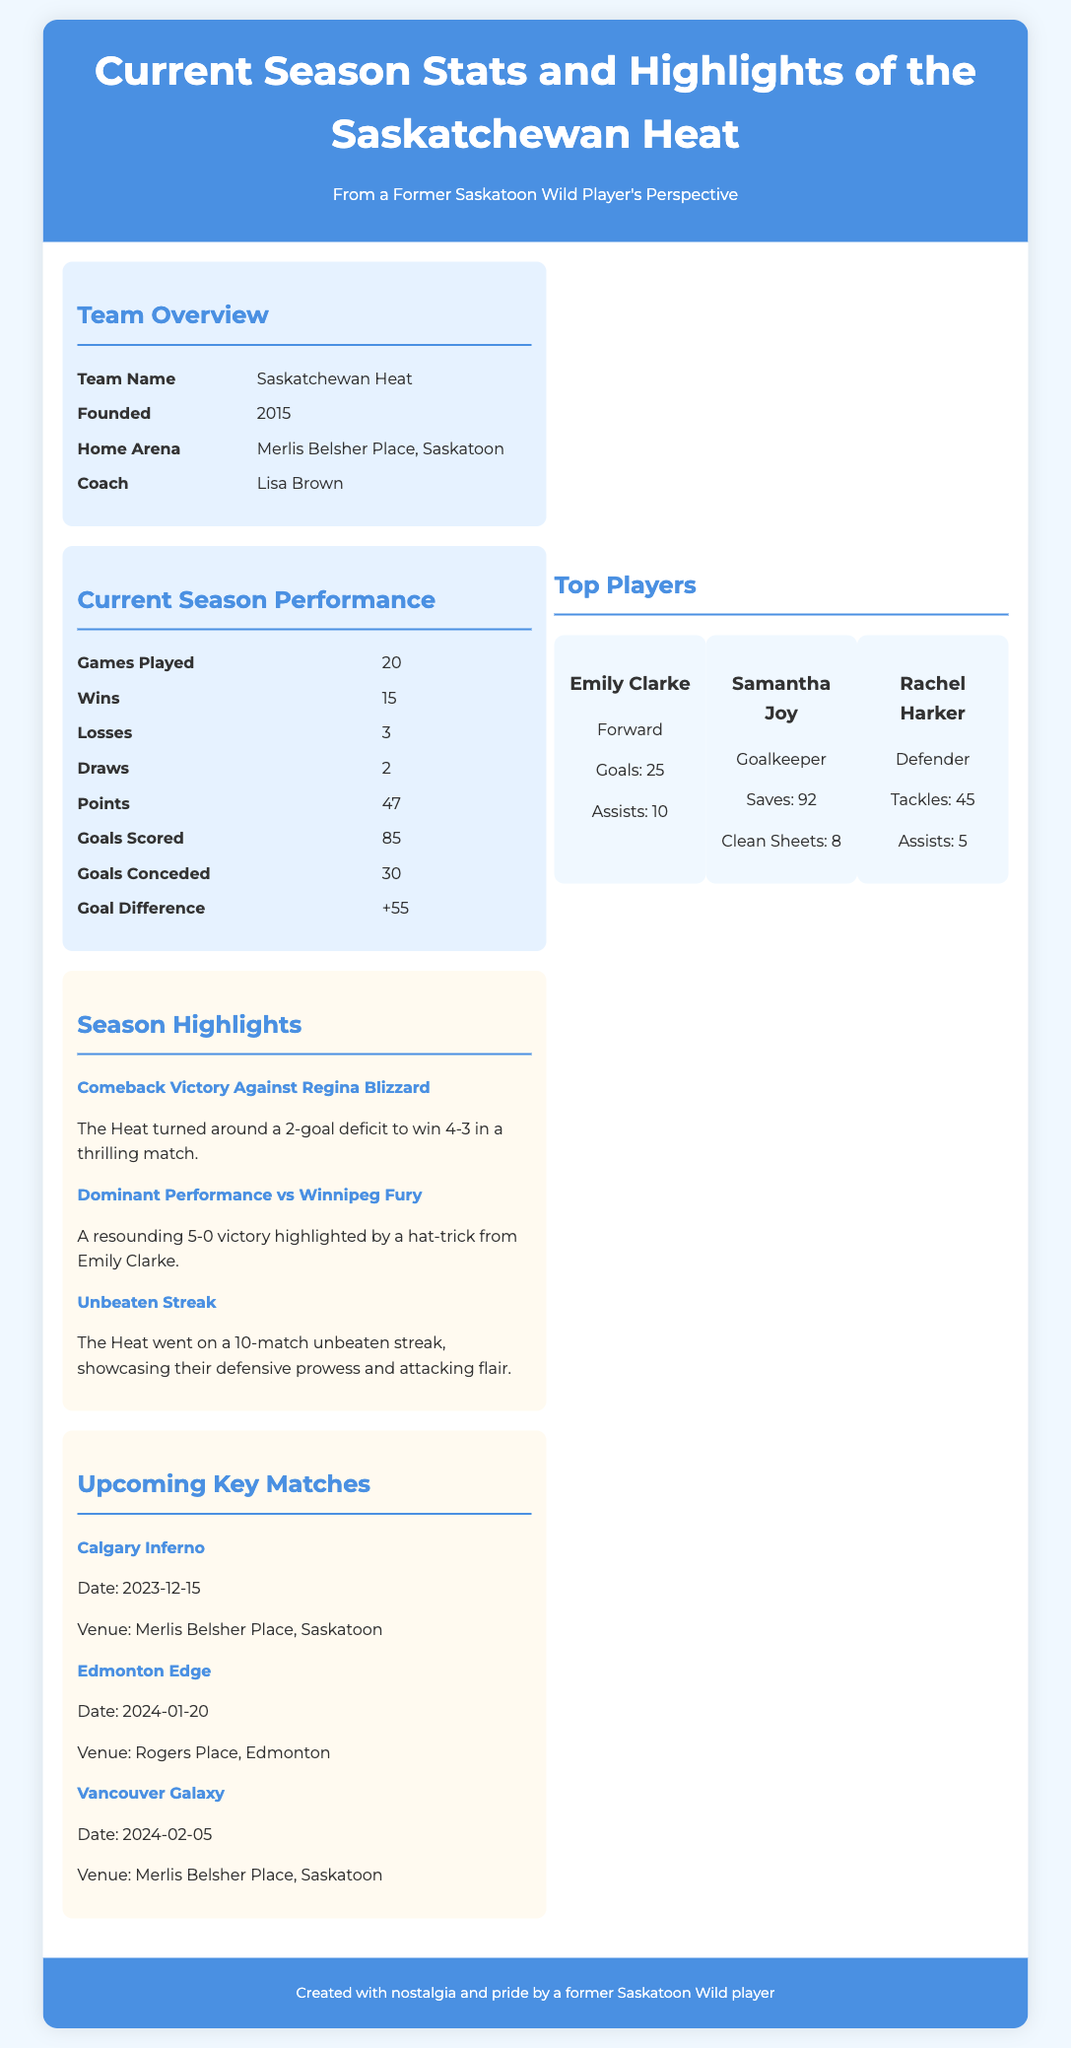what is the name of the team? The document states that the team's name is the Saskatchewan Heat.
Answer: Saskatchewan Heat who is the coach? According to the document, the coach of the team is Lisa Brown.
Answer: Lisa Brown how many games have been played this season? The document indicates that the Saskatchewan Heat has played 20 games this season.
Answer: 20 what is the goal difference? The goal difference listed in the document for the current season is +55.
Answer: +55 how many goals did Emily Clarke score? The document details that Emily Clarke scored 25 goals in the current season.
Answer: 25 what was the score in the match against Winnipeg Fury? In the document, it is highlighted that the Heat won against Winnipeg Fury with a score of 5-0.
Answer: 5-0 how many upcoming matches are listed? The document mentions three upcoming key matches for the Saskatchewan Heat.
Answer: 3 what was the result of the comeback victory against Regina Blizzard? The document states that the Heat turned around a 2-goal deficit to win the match 4-3.
Answer: 4-3 when is the next match against Calgary Inferno? The document specifies that the next match against Calgary Inferno is scheduled for December 15, 2023.
Answer: December 15, 2023 